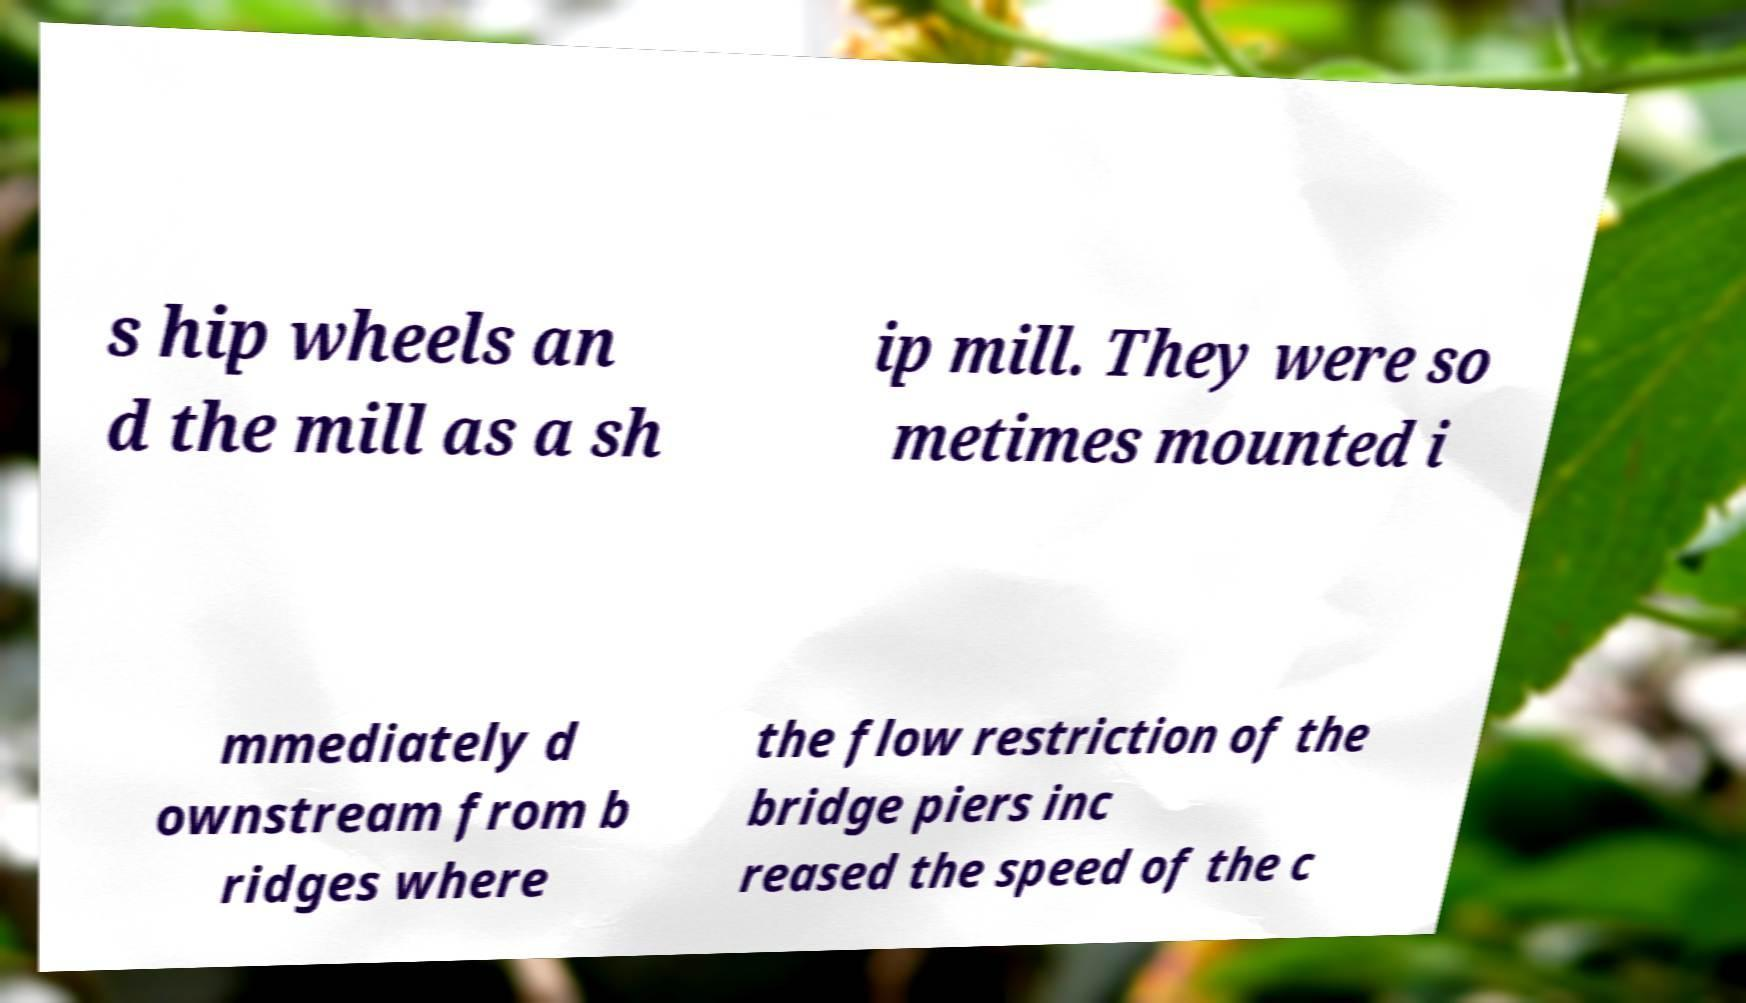Please read and relay the text visible in this image. What does it say? s hip wheels an d the mill as a sh ip mill. They were so metimes mounted i mmediately d ownstream from b ridges where the flow restriction of the bridge piers inc reased the speed of the c 